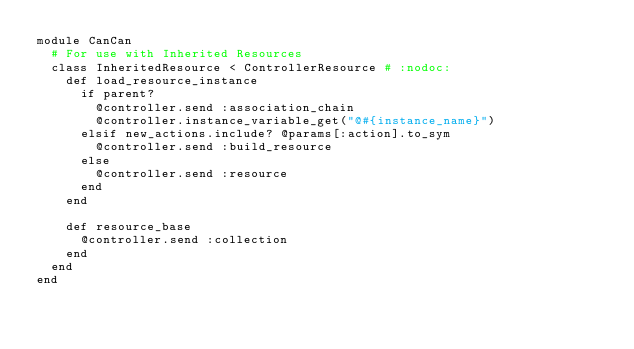Convert code to text. <code><loc_0><loc_0><loc_500><loc_500><_Ruby_>module CanCan
  # For use with Inherited Resources
  class InheritedResource < ControllerResource # :nodoc:
    def load_resource_instance
      if parent?
        @controller.send :association_chain
        @controller.instance_variable_get("@#{instance_name}")
      elsif new_actions.include? @params[:action].to_sym
        @controller.send :build_resource
      else
        @controller.send :resource
      end
    end

    def resource_base
      @controller.send :collection
    end
  end
end
</code> 